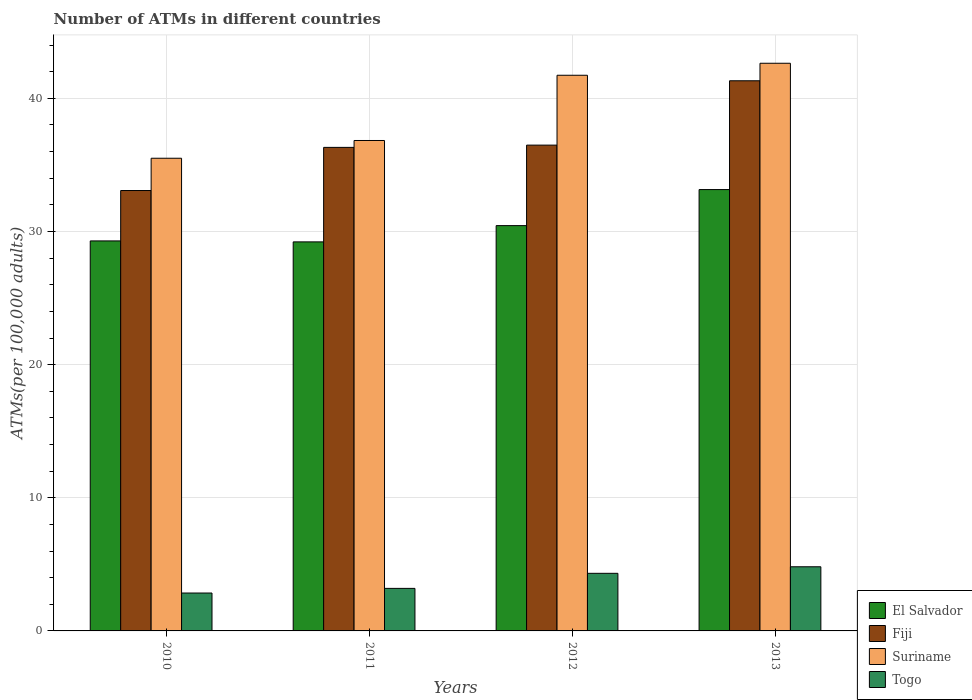How many different coloured bars are there?
Your response must be concise. 4. How many groups of bars are there?
Offer a terse response. 4. What is the label of the 1st group of bars from the left?
Provide a short and direct response. 2010. In how many cases, is the number of bars for a given year not equal to the number of legend labels?
Provide a short and direct response. 0. What is the number of ATMs in Togo in 2013?
Ensure brevity in your answer.  4.82. Across all years, what is the maximum number of ATMs in Togo?
Provide a succinct answer. 4.82. Across all years, what is the minimum number of ATMs in Suriname?
Offer a terse response. 35.5. What is the total number of ATMs in Suriname in the graph?
Your answer should be very brief. 156.71. What is the difference between the number of ATMs in El Salvador in 2010 and that in 2012?
Provide a short and direct response. -1.15. What is the difference between the number of ATMs in Togo in 2010 and the number of ATMs in Suriname in 2013?
Give a very brief answer. -39.79. What is the average number of ATMs in Suriname per year?
Keep it short and to the point. 39.18. In the year 2012, what is the difference between the number of ATMs in Fiji and number of ATMs in Suriname?
Your response must be concise. -5.25. In how many years, is the number of ATMs in Togo greater than 34?
Provide a short and direct response. 0. What is the ratio of the number of ATMs in El Salvador in 2011 to that in 2012?
Ensure brevity in your answer.  0.96. What is the difference between the highest and the second highest number of ATMs in Togo?
Make the answer very short. 0.49. What is the difference between the highest and the lowest number of ATMs in Fiji?
Keep it short and to the point. 8.24. In how many years, is the number of ATMs in El Salvador greater than the average number of ATMs in El Salvador taken over all years?
Make the answer very short. 1. Is it the case that in every year, the sum of the number of ATMs in El Salvador and number of ATMs in Suriname is greater than the sum of number of ATMs in Togo and number of ATMs in Fiji?
Your response must be concise. No. What does the 4th bar from the left in 2013 represents?
Your response must be concise. Togo. What does the 1st bar from the right in 2012 represents?
Provide a short and direct response. Togo. Is it the case that in every year, the sum of the number of ATMs in Fiji and number of ATMs in El Salvador is greater than the number of ATMs in Togo?
Offer a very short reply. Yes. Are all the bars in the graph horizontal?
Offer a very short reply. No. How many years are there in the graph?
Your response must be concise. 4. What is the difference between two consecutive major ticks on the Y-axis?
Make the answer very short. 10. Are the values on the major ticks of Y-axis written in scientific E-notation?
Make the answer very short. No. How many legend labels are there?
Your response must be concise. 4. How are the legend labels stacked?
Your answer should be very brief. Vertical. What is the title of the graph?
Your answer should be very brief. Number of ATMs in different countries. Does "Austria" appear as one of the legend labels in the graph?
Ensure brevity in your answer.  No. What is the label or title of the X-axis?
Offer a terse response. Years. What is the label or title of the Y-axis?
Your answer should be compact. ATMs(per 100,0 adults). What is the ATMs(per 100,000 adults) in El Salvador in 2010?
Your response must be concise. 29.29. What is the ATMs(per 100,000 adults) of Fiji in 2010?
Provide a succinct answer. 33.08. What is the ATMs(per 100,000 adults) in Suriname in 2010?
Offer a very short reply. 35.5. What is the ATMs(per 100,000 adults) in Togo in 2010?
Your answer should be compact. 2.85. What is the ATMs(per 100,000 adults) in El Salvador in 2011?
Offer a very short reply. 29.22. What is the ATMs(per 100,000 adults) of Fiji in 2011?
Your response must be concise. 36.32. What is the ATMs(per 100,000 adults) of Suriname in 2011?
Ensure brevity in your answer.  36.83. What is the ATMs(per 100,000 adults) in Togo in 2011?
Offer a terse response. 3.2. What is the ATMs(per 100,000 adults) in El Salvador in 2012?
Offer a terse response. 30.44. What is the ATMs(per 100,000 adults) in Fiji in 2012?
Offer a terse response. 36.49. What is the ATMs(per 100,000 adults) of Suriname in 2012?
Your answer should be very brief. 41.73. What is the ATMs(per 100,000 adults) in Togo in 2012?
Ensure brevity in your answer.  4.33. What is the ATMs(per 100,000 adults) of El Salvador in 2013?
Keep it short and to the point. 33.15. What is the ATMs(per 100,000 adults) of Fiji in 2013?
Your answer should be compact. 41.32. What is the ATMs(per 100,000 adults) in Suriname in 2013?
Provide a short and direct response. 42.64. What is the ATMs(per 100,000 adults) of Togo in 2013?
Your response must be concise. 4.82. Across all years, what is the maximum ATMs(per 100,000 adults) in El Salvador?
Your response must be concise. 33.15. Across all years, what is the maximum ATMs(per 100,000 adults) of Fiji?
Offer a terse response. 41.32. Across all years, what is the maximum ATMs(per 100,000 adults) of Suriname?
Your response must be concise. 42.64. Across all years, what is the maximum ATMs(per 100,000 adults) of Togo?
Your answer should be very brief. 4.82. Across all years, what is the minimum ATMs(per 100,000 adults) in El Salvador?
Ensure brevity in your answer.  29.22. Across all years, what is the minimum ATMs(per 100,000 adults) of Fiji?
Keep it short and to the point. 33.08. Across all years, what is the minimum ATMs(per 100,000 adults) in Suriname?
Offer a terse response. 35.5. Across all years, what is the minimum ATMs(per 100,000 adults) of Togo?
Your response must be concise. 2.85. What is the total ATMs(per 100,000 adults) in El Salvador in the graph?
Provide a succinct answer. 122.1. What is the total ATMs(per 100,000 adults) of Fiji in the graph?
Your answer should be compact. 147.2. What is the total ATMs(per 100,000 adults) of Suriname in the graph?
Provide a succinct answer. 156.71. What is the total ATMs(per 100,000 adults) in Togo in the graph?
Your answer should be compact. 15.19. What is the difference between the ATMs(per 100,000 adults) of El Salvador in 2010 and that in 2011?
Provide a short and direct response. 0.07. What is the difference between the ATMs(per 100,000 adults) in Fiji in 2010 and that in 2011?
Provide a short and direct response. -3.24. What is the difference between the ATMs(per 100,000 adults) in Suriname in 2010 and that in 2011?
Provide a short and direct response. -1.33. What is the difference between the ATMs(per 100,000 adults) in Togo in 2010 and that in 2011?
Offer a very short reply. -0.35. What is the difference between the ATMs(per 100,000 adults) of El Salvador in 2010 and that in 2012?
Ensure brevity in your answer.  -1.15. What is the difference between the ATMs(per 100,000 adults) of Fiji in 2010 and that in 2012?
Make the answer very short. -3.41. What is the difference between the ATMs(per 100,000 adults) in Suriname in 2010 and that in 2012?
Make the answer very short. -6.23. What is the difference between the ATMs(per 100,000 adults) of Togo in 2010 and that in 2012?
Offer a terse response. -1.48. What is the difference between the ATMs(per 100,000 adults) in El Salvador in 2010 and that in 2013?
Ensure brevity in your answer.  -3.86. What is the difference between the ATMs(per 100,000 adults) of Fiji in 2010 and that in 2013?
Ensure brevity in your answer.  -8.24. What is the difference between the ATMs(per 100,000 adults) of Suriname in 2010 and that in 2013?
Make the answer very short. -7.13. What is the difference between the ATMs(per 100,000 adults) of Togo in 2010 and that in 2013?
Provide a short and direct response. -1.97. What is the difference between the ATMs(per 100,000 adults) in El Salvador in 2011 and that in 2012?
Keep it short and to the point. -1.22. What is the difference between the ATMs(per 100,000 adults) in Fiji in 2011 and that in 2012?
Provide a succinct answer. -0.17. What is the difference between the ATMs(per 100,000 adults) in Suriname in 2011 and that in 2012?
Make the answer very short. -4.9. What is the difference between the ATMs(per 100,000 adults) of Togo in 2011 and that in 2012?
Your answer should be compact. -1.13. What is the difference between the ATMs(per 100,000 adults) of El Salvador in 2011 and that in 2013?
Ensure brevity in your answer.  -3.93. What is the difference between the ATMs(per 100,000 adults) of Fiji in 2011 and that in 2013?
Your response must be concise. -5. What is the difference between the ATMs(per 100,000 adults) in Suriname in 2011 and that in 2013?
Offer a very short reply. -5.8. What is the difference between the ATMs(per 100,000 adults) of Togo in 2011 and that in 2013?
Offer a very short reply. -1.62. What is the difference between the ATMs(per 100,000 adults) in El Salvador in 2012 and that in 2013?
Your response must be concise. -2.71. What is the difference between the ATMs(per 100,000 adults) of Fiji in 2012 and that in 2013?
Your response must be concise. -4.83. What is the difference between the ATMs(per 100,000 adults) in Suriname in 2012 and that in 2013?
Offer a terse response. -0.9. What is the difference between the ATMs(per 100,000 adults) in Togo in 2012 and that in 2013?
Offer a very short reply. -0.49. What is the difference between the ATMs(per 100,000 adults) in El Salvador in 2010 and the ATMs(per 100,000 adults) in Fiji in 2011?
Make the answer very short. -7.03. What is the difference between the ATMs(per 100,000 adults) of El Salvador in 2010 and the ATMs(per 100,000 adults) of Suriname in 2011?
Keep it short and to the point. -7.54. What is the difference between the ATMs(per 100,000 adults) of El Salvador in 2010 and the ATMs(per 100,000 adults) of Togo in 2011?
Make the answer very short. 26.1. What is the difference between the ATMs(per 100,000 adults) in Fiji in 2010 and the ATMs(per 100,000 adults) in Suriname in 2011?
Offer a terse response. -3.76. What is the difference between the ATMs(per 100,000 adults) of Fiji in 2010 and the ATMs(per 100,000 adults) of Togo in 2011?
Give a very brief answer. 29.88. What is the difference between the ATMs(per 100,000 adults) of Suriname in 2010 and the ATMs(per 100,000 adults) of Togo in 2011?
Ensure brevity in your answer.  32.31. What is the difference between the ATMs(per 100,000 adults) of El Salvador in 2010 and the ATMs(per 100,000 adults) of Fiji in 2012?
Provide a short and direct response. -7.2. What is the difference between the ATMs(per 100,000 adults) in El Salvador in 2010 and the ATMs(per 100,000 adults) in Suriname in 2012?
Your answer should be compact. -12.44. What is the difference between the ATMs(per 100,000 adults) in El Salvador in 2010 and the ATMs(per 100,000 adults) in Togo in 2012?
Ensure brevity in your answer.  24.97. What is the difference between the ATMs(per 100,000 adults) of Fiji in 2010 and the ATMs(per 100,000 adults) of Suriname in 2012?
Provide a short and direct response. -8.66. What is the difference between the ATMs(per 100,000 adults) in Fiji in 2010 and the ATMs(per 100,000 adults) in Togo in 2012?
Your response must be concise. 28.75. What is the difference between the ATMs(per 100,000 adults) in Suriname in 2010 and the ATMs(per 100,000 adults) in Togo in 2012?
Offer a very short reply. 31.18. What is the difference between the ATMs(per 100,000 adults) of El Salvador in 2010 and the ATMs(per 100,000 adults) of Fiji in 2013?
Ensure brevity in your answer.  -12.03. What is the difference between the ATMs(per 100,000 adults) in El Salvador in 2010 and the ATMs(per 100,000 adults) in Suriname in 2013?
Your answer should be compact. -13.34. What is the difference between the ATMs(per 100,000 adults) of El Salvador in 2010 and the ATMs(per 100,000 adults) of Togo in 2013?
Keep it short and to the point. 24.47. What is the difference between the ATMs(per 100,000 adults) in Fiji in 2010 and the ATMs(per 100,000 adults) in Suriname in 2013?
Provide a short and direct response. -9.56. What is the difference between the ATMs(per 100,000 adults) of Fiji in 2010 and the ATMs(per 100,000 adults) of Togo in 2013?
Ensure brevity in your answer.  28.26. What is the difference between the ATMs(per 100,000 adults) in Suriname in 2010 and the ATMs(per 100,000 adults) in Togo in 2013?
Ensure brevity in your answer.  30.68. What is the difference between the ATMs(per 100,000 adults) of El Salvador in 2011 and the ATMs(per 100,000 adults) of Fiji in 2012?
Offer a very short reply. -7.27. What is the difference between the ATMs(per 100,000 adults) of El Salvador in 2011 and the ATMs(per 100,000 adults) of Suriname in 2012?
Your answer should be very brief. -12.51. What is the difference between the ATMs(per 100,000 adults) of El Salvador in 2011 and the ATMs(per 100,000 adults) of Togo in 2012?
Ensure brevity in your answer.  24.89. What is the difference between the ATMs(per 100,000 adults) of Fiji in 2011 and the ATMs(per 100,000 adults) of Suriname in 2012?
Ensure brevity in your answer.  -5.42. What is the difference between the ATMs(per 100,000 adults) in Fiji in 2011 and the ATMs(per 100,000 adults) in Togo in 2012?
Provide a short and direct response. 31.99. What is the difference between the ATMs(per 100,000 adults) of Suriname in 2011 and the ATMs(per 100,000 adults) of Togo in 2012?
Make the answer very short. 32.51. What is the difference between the ATMs(per 100,000 adults) of El Salvador in 2011 and the ATMs(per 100,000 adults) of Fiji in 2013?
Your response must be concise. -12.1. What is the difference between the ATMs(per 100,000 adults) in El Salvador in 2011 and the ATMs(per 100,000 adults) in Suriname in 2013?
Your answer should be compact. -13.42. What is the difference between the ATMs(per 100,000 adults) in El Salvador in 2011 and the ATMs(per 100,000 adults) in Togo in 2013?
Keep it short and to the point. 24.4. What is the difference between the ATMs(per 100,000 adults) of Fiji in 2011 and the ATMs(per 100,000 adults) of Suriname in 2013?
Make the answer very short. -6.32. What is the difference between the ATMs(per 100,000 adults) in Fiji in 2011 and the ATMs(per 100,000 adults) in Togo in 2013?
Provide a short and direct response. 31.5. What is the difference between the ATMs(per 100,000 adults) of Suriname in 2011 and the ATMs(per 100,000 adults) of Togo in 2013?
Offer a terse response. 32.02. What is the difference between the ATMs(per 100,000 adults) in El Salvador in 2012 and the ATMs(per 100,000 adults) in Fiji in 2013?
Provide a succinct answer. -10.88. What is the difference between the ATMs(per 100,000 adults) of El Salvador in 2012 and the ATMs(per 100,000 adults) of Suriname in 2013?
Provide a succinct answer. -12.19. What is the difference between the ATMs(per 100,000 adults) in El Salvador in 2012 and the ATMs(per 100,000 adults) in Togo in 2013?
Ensure brevity in your answer.  25.62. What is the difference between the ATMs(per 100,000 adults) of Fiji in 2012 and the ATMs(per 100,000 adults) of Suriname in 2013?
Your answer should be very brief. -6.15. What is the difference between the ATMs(per 100,000 adults) of Fiji in 2012 and the ATMs(per 100,000 adults) of Togo in 2013?
Your answer should be very brief. 31.67. What is the difference between the ATMs(per 100,000 adults) in Suriname in 2012 and the ATMs(per 100,000 adults) in Togo in 2013?
Make the answer very short. 36.92. What is the average ATMs(per 100,000 adults) in El Salvador per year?
Offer a terse response. 30.53. What is the average ATMs(per 100,000 adults) in Fiji per year?
Keep it short and to the point. 36.8. What is the average ATMs(per 100,000 adults) of Suriname per year?
Offer a terse response. 39.18. What is the average ATMs(per 100,000 adults) in Togo per year?
Offer a very short reply. 3.8. In the year 2010, what is the difference between the ATMs(per 100,000 adults) of El Salvador and ATMs(per 100,000 adults) of Fiji?
Your answer should be compact. -3.79. In the year 2010, what is the difference between the ATMs(per 100,000 adults) in El Salvador and ATMs(per 100,000 adults) in Suriname?
Provide a succinct answer. -6.21. In the year 2010, what is the difference between the ATMs(per 100,000 adults) of El Salvador and ATMs(per 100,000 adults) of Togo?
Your answer should be very brief. 26.45. In the year 2010, what is the difference between the ATMs(per 100,000 adults) in Fiji and ATMs(per 100,000 adults) in Suriname?
Offer a terse response. -2.42. In the year 2010, what is the difference between the ATMs(per 100,000 adults) in Fiji and ATMs(per 100,000 adults) in Togo?
Your answer should be very brief. 30.23. In the year 2010, what is the difference between the ATMs(per 100,000 adults) of Suriname and ATMs(per 100,000 adults) of Togo?
Keep it short and to the point. 32.66. In the year 2011, what is the difference between the ATMs(per 100,000 adults) of El Salvador and ATMs(per 100,000 adults) of Fiji?
Provide a succinct answer. -7.1. In the year 2011, what is the difference between the ATMs(per 100,000 adults) in El Salvador and ATMs(per 100,000 adults) in Suriname?
Your answer should be compact. -7.61. In the year 2011, what is the difference between the ATMs(per 100,000 adults) in El Salvador and ATMs(per 100,000 adults) in Togo?
Provide a short and direct response. 26.02. In the year 2011, what is the difference between the ATMs(per 100,000 adults) in Fiji and ATMs(per 100,000 adults) in Suriname?
Ensure brevity in your answer.  -0.52. In the year 2011, what is the difference between the ATMs(per 100,000 adults) in Fiji and ATMs(per 100,000 adults) in Togo?
Your answer should be very brief. 33.12. In the year 2011, what is the difference between the ATMs(per 100,000 adults) in Suriname and ATMs(per 100,000 adults) in Togo?
Keep it short and to the point. 33.64. In the year 2012, what is the difference between the ATMs(per 100,000 adults) in El Salvador and ATMs(per 100,000 adults) in Fiji?
Ensure brevity in your answer.  -6.05. In the year 2012, what is the difference between the ATMs(per 100,000 adults) in El Salvador and ATMs(per 100,000 adults) in Suriname?
Your response must be concise. -11.29. In the year 2012, what is the difference between the ATMs(per 100,000 adults) of El Salvador and ATMs(per 100,000 adults) of Togo?
Offer a terse response. 26.12. In the year 2012, what is the difference between the ATMs(per 100,000 adults) of Fiji and ATMs(per 100,000 adults) of Suriname?
Your response must be concise. -5.25. In the year 2012, what is the difference between the ATMs(per 100,000 adults) in Fiji and ATMs(per 100,000 adults) in Togo?
Keep it short and to the point. 32.16. In the year 2012, what is the difference between the ATMs(per 100,000 adults) in Suriname and ATMs(per 100,000 adults) in Togo?
Make the answer very short. 37.41. In the year 2013, what is the difference between the ATMs(per 100,000 adults) of El Salvador and ATMs(per 100,000 adults) of Fiji?
Make the answer very short. -8.17. In the year 2013, what is the difference between the ATMs(per 100,000 adults) of El Salvador and ATMs(per 100,000 adults) of Suriname?
Make the answer very short. -9.49. In the year 2013, what is the difference between the ATMs(per 100,000 adults) in El Salvador and ATMs(per 100,000 adults) in Togo?
Make the answer very short. 28.33. In the year 2013, what is the difference between the ATMs(per 100,000 adults) of Fiji and ATMs(per 100,000 adults) of Suriname?
Ensure brevity in your answer.  -1.31. In the year 2013, what is the difference between the ATMs(per 100,000 adults) in Fiji and ATMs(per 100,000 adults) in Togo?
Provide a succinct answer. 36.5. In the year 2013, what is the difference between the ATMs(per 100,000 adults) in Suriname and ATMs(per 100,000 adults) in Togo?
Give a very brief answer. 37.82. What is the ratio of the ATMs(per 100,000 adults) of El Salvador in 2010 to that in 2011?
Offer a terse response. 1. What is the ratio of the ATMs(per 100,000 adults) of Fiji in 2010 to that in 2011?
Offer a very short reply. 0.91. What is the ratio of the ATMs(per 100,000 adults) of Suriname in 2010 to that in 2011?
Make the answer very short. 0.96. What is the ratio of the ATMs(per 100,000 adults) of Togo in 2010 to that in 2011?
Make the answer very short. 0.89. What is the ratio of the ATMs(per 100,000 adults) of El Salvador in 2010 to that in 2012?
Your answer should be very brief. 0.96. What is the ratio of the ATMs(per 100,000 adults) of Fiji in 2010 to that in 2012?
Offer a very short reply. 0.91. What is the ratio of the ATMs(per 100,000 adults) of Suriname in 2010 to that in 2012?
Give a very brief answer. 0.85. What is the ratio of the ATMs(per 100,000 adults) in Togo in 2010 to that in 2012?
Give a very brief answer. 0.66. What is the ratio of the ATMs(per 100,000 adults) of El Salvador in 2010 to that in 2013?
Ensure brevity in your answer.  0.88. What is the ratio of the ATMs(per 100,000 adults) in Fiji in 2010 to that in 2013?
Offer a very short reply. 0.8. What is the ratio of the ATMs(per 100,000 adults) in Suriname in 2010 to that in 2013?
Your answer should be compact. 0.83. What is the ratio of the ATMs(per 100,000 adults) of Togo in 2010 to that in 2013?
Provide a short and direct response. 0.59. What is the ratio of the ATMs(per 100,000 adults) of El Salvador in 2011 to that in 2012?
Offer a terse response. 0.96. What is the ratio of the ATMs(per 100,000 adults) in Fiji in 2011 to that in 2012?
Make the answer very short. 1. What is the ratio of the ATMs(per 100,000 adults) in Suriname in 2011 to that in 2012?
Keep it short and to the point. 0.88. What is the ratio of the ATMs(per 100,000 adults) of Togo in 2011 to that in 2012?
Your answer should be compact. 0.74. What is the ratio of the ATMs(per 100,000 adults) in El Salvador in 2011 to that in 2013?
Make the answer very short. 0.88. What is the ratio of the ATMs(per 100,000 adults) of Fiji in 2011 to that in 2013?
Make the answer very short. 0.88. What is the ratio of the ATMs(per 100,000 adults) in Suriname in 2011 to that in 2013?
Your answer should be very brief. 0.86. What is the ratio of the ATMs(per 100,000 adults) of Togo in 2011 to that in 2013?
Offer a terse response. 0.66. What is the ratio of the ATMs(per 100,000 adults) of El Salvador in 2012 to that in 2013?
Your response must be concise. 0.92. What is the ratio of the ATMs(per 100,000 adults) of Fiji in 2012 to that in 2013?
Ensure brevity in your answer.  0.88. What is the ratio of the ATMs(per 100,000 adults) in Suriname in 2012 to that in 2013?
Your answer should be compact. 0.98. What is the ratio of the ATMs(per 100,000 adults) in Togo in 2012 to that in 2013?
Your answer should be compact. 0.9. What is the difference between the highest and the second highest ATMs(per 100,000 adults) of El Salvador?
Offer a terse response. 2.71. What is the difference between the highest and the second highest ATMs(per 100,000 adults) in Fiji?
Make the answer very short. 4.83. What is the difference between the highest and the second highest ATMs(per 100,000 adults) of Suriname?
Make the answer very short. 0.9. What is the difference between the highest and the second highest ATMs(per 100,000 adults) in Togo?
Your answer should be compact. 0.49. What is the difference between the highest and the lowest ATMs(per 100,000 adults) in El Salvador?
Make the answer very short. 3.93. What is the difference between the highest and the lowest ATMs(per 100,000 adults) in Fiji?
Give a very brief answer. 8.24. What is the difference between the highest and the lowest ATMs(per 100,000 adults) in Suriname?
Ensure brevity in your answer.  7.13. What is the difference between the highest and the lowest ATMs(per 100,000 adults) in Togo?
Offer a very short reply. 1.97. 